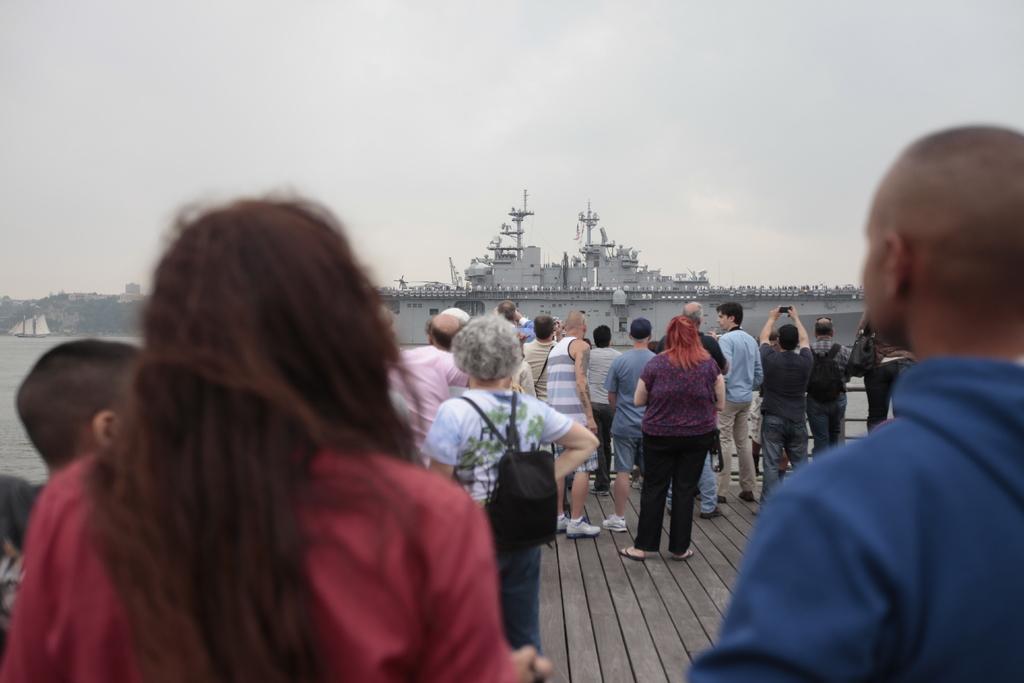Can you describe this image briefly? In this image there are group of people standing on the wooden floor and looking at the ship which is in front of them. The ship is in the water. At the top there is the sky. In the background there are buildings. 